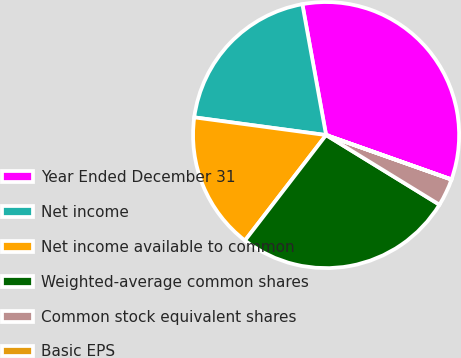Convert chart. <chart><loc_0><loc_0><loc_500><loc_500><pie_chart><fcel>Year Ended December 31<fcel>Net income<fcel>Net income available to common<fcel>Weighted-average common shares<fcel>Common stock equivalent shares<fcel>Basic EPS<nl><fcel>33.27%<fcel>20.02%<fcel>16.69%<fcel>26.67%<fcel>3.34%<fcel>0.01%<nl></chart> 